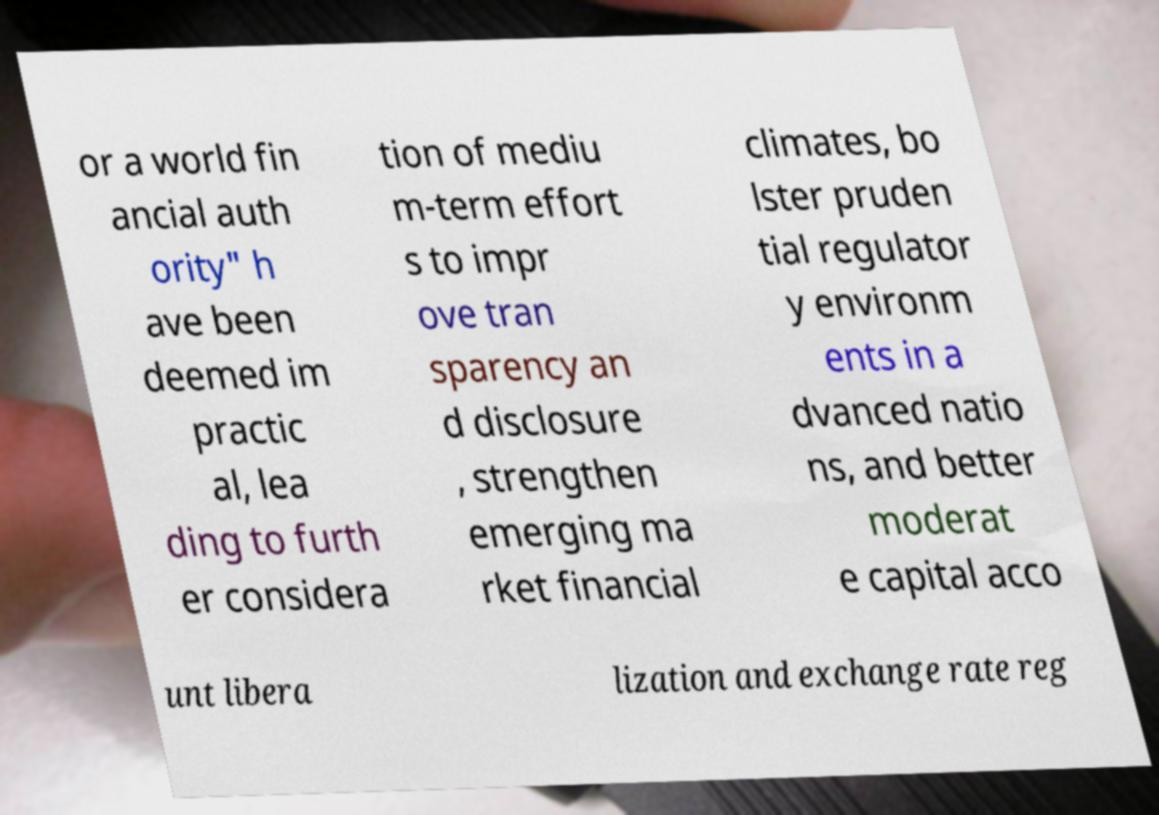For documentation purposes, I need the text within this image transcribed. Could you provide that? or a world fin ancial auth ority" h ave been deemed im practic al, lea ding to furth er considera tion of mediu m-term effort s to impr ove tran sparency an d disclosure , strengthen emerging ma rket financial climates, bo lster pruden tial regulator y environm ents in a dvanced natio ns, and better moderat e capital acco unt libera lization and exchange rate reg 